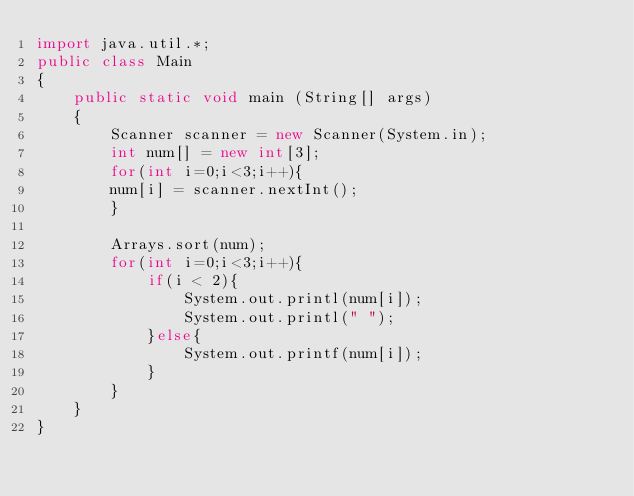Convert code to text. <code><loc_0><loc_0><loc_500><loc_500><_Java_>import java.util.*;
public class Main
{
    public static void main (String[] args)
    {
        Scanner scanner = new Scanner(System.in);
    	int num[] = new int[3];
    	for(int i=0;i<3;i++){
    	num[i] = scanner.nextInt();
    	}
    	
    	Arrays.sort(num);
    	for(int i=0;i<3;i++){
    		if(i < 2){
    			System.out.printl(num[i]);
    			System.out.printl(" ");
    		}else{
    			System.out.printf(num[i]);
    		}
    	}
    }
}</code> 